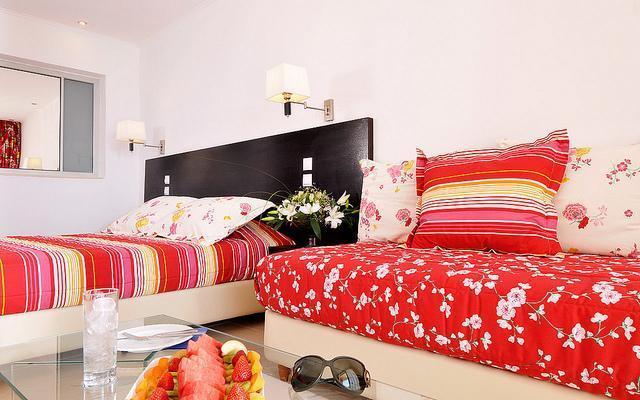How many giraffes are holding their neck horizontally?
Give a very brief answer. 0. 